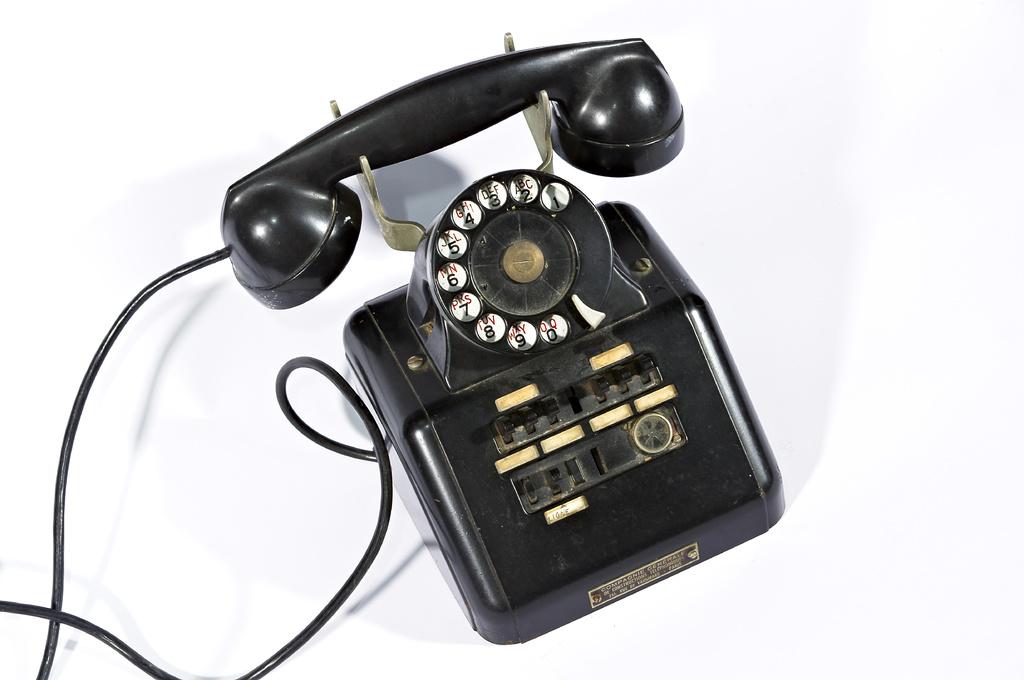What number has abc on it?
Offer a terse response. 2. What letters are on the number 3?
Provide a succinct answer. Def. 